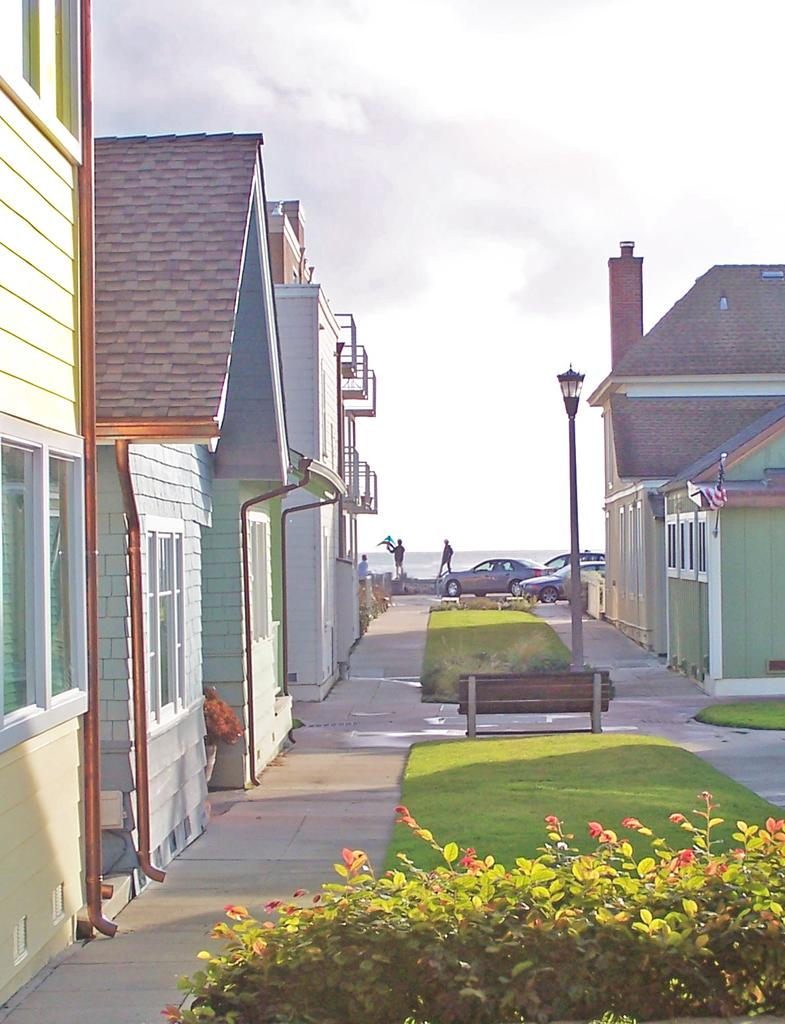What type of vegetation is present in the image? There is grass and plants in the image. What structures can be seen in the image? There are poles with buildings in the image. What is visible in the background of the image? There is an ocean in the background of the image. What can be observed about the people in the image? There are people standing in the image. What is the condition of the sky in the image? The sky is clear in the image. What types of toys are the people playing with in the image? There are no toys present in the image; it features people standing near poles with buildings, grass, plants, and an ocean in the background. What hobbies do the people in the image have? There is no information about the people's hobbies in the image. 